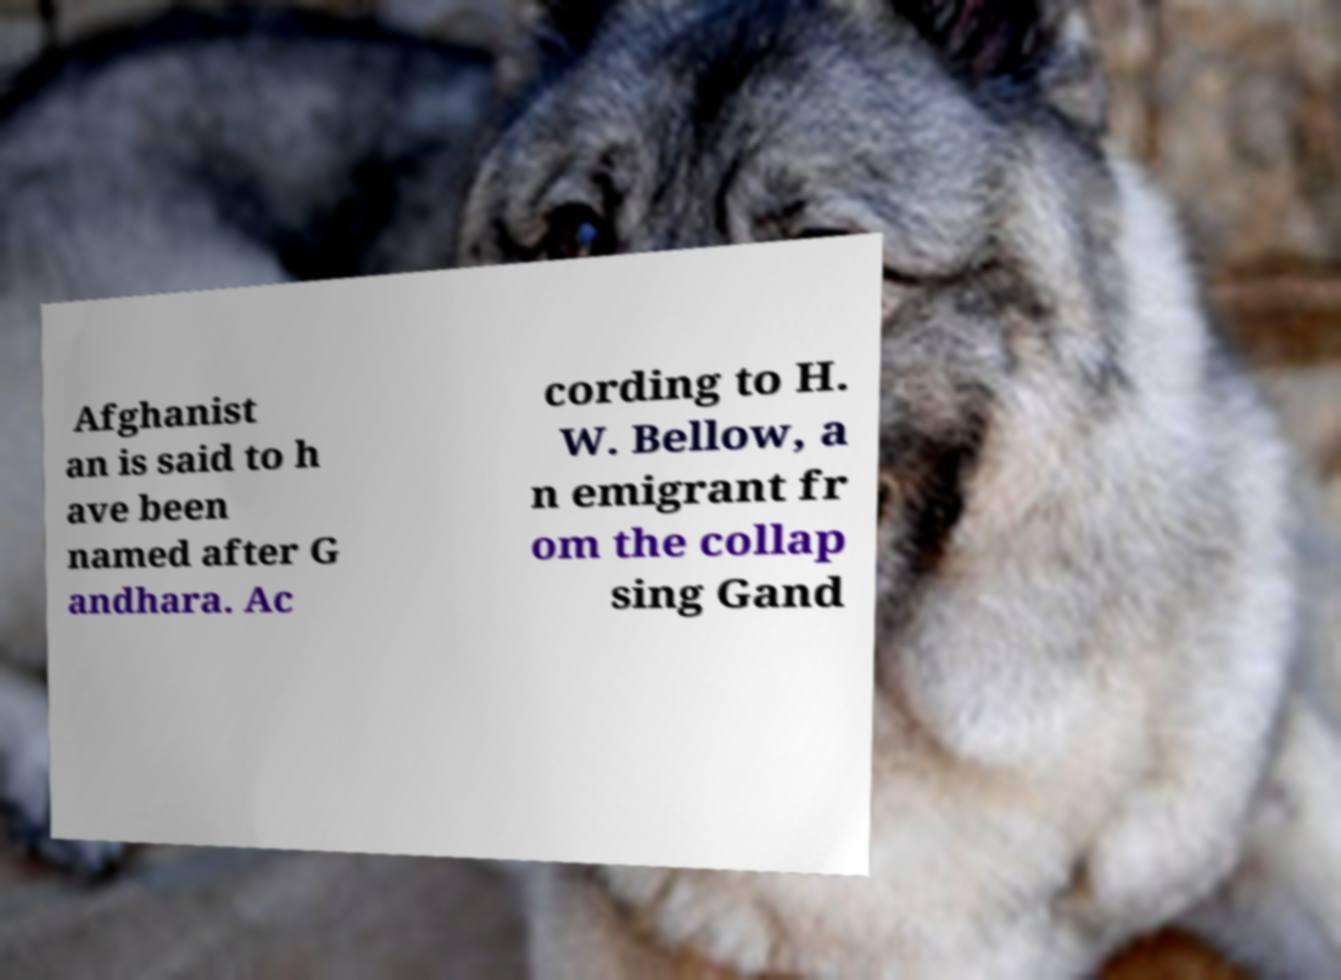What messages or text are displayed in this image? I need them in a readable, typed format. Afghanist an is said to h ave been named after G andhara. Ac cording to H. W. Bellow, a n emigrant fr om the collap sing Gand 